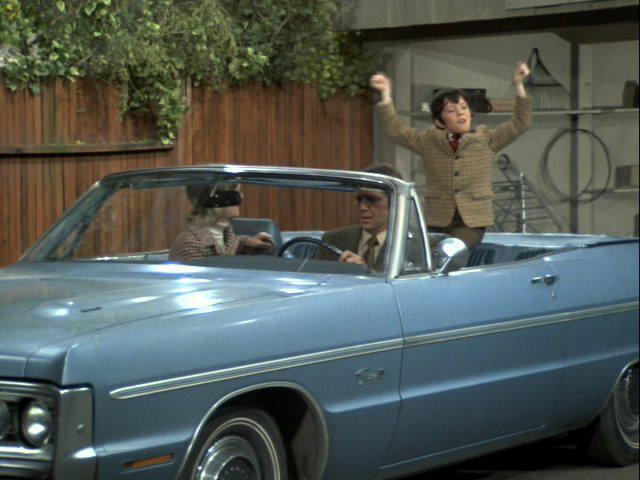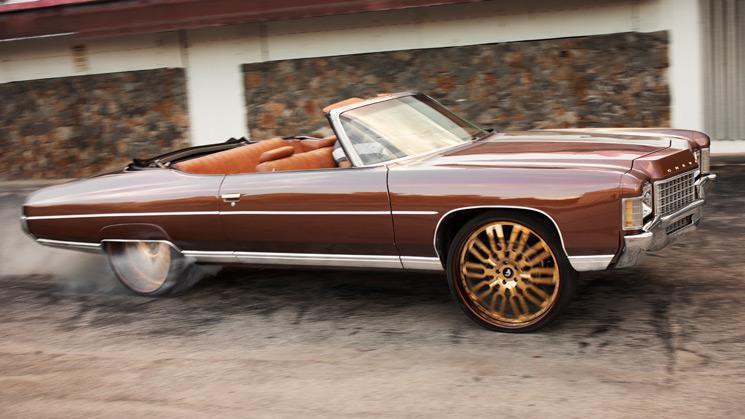The first image is the image on the left, the second image is the image on the right. For the images displayed, is the sentence "Two convertibles with tops completely down are different colors and facing different directions." factually correct? Answer yes or no. Yes. The first image is the image on the left, the second image is the image on the right. Given the left and right images, does the statement "The red car on the right is sitting in the driveway." hold true? Answer yes or no. Yes. 